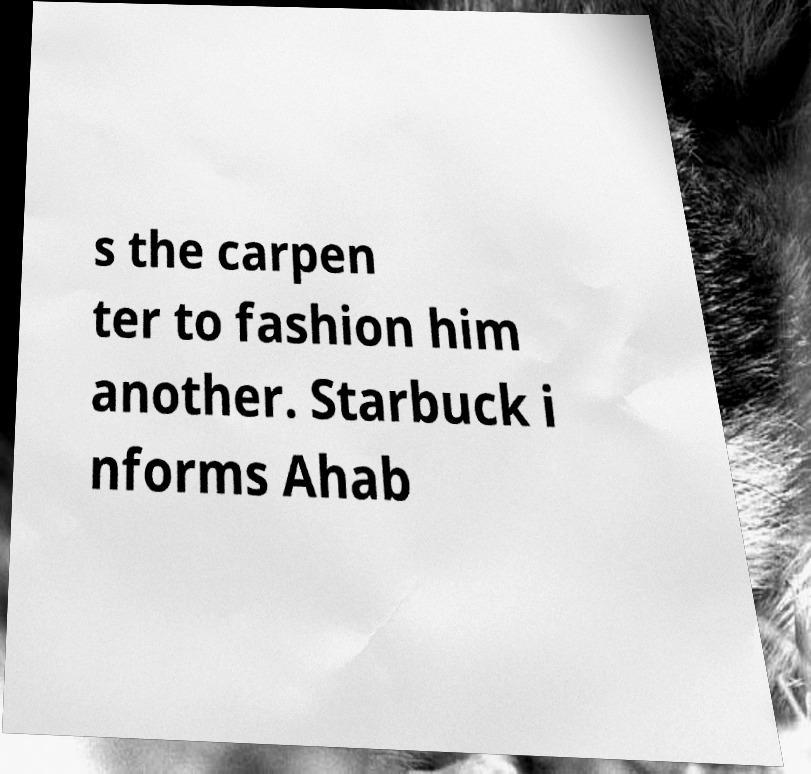Can you read and provide the text displayed in the image?This photo seems to have some interesting text. Can you extract and type it out for me? s the carpen ter to fashion him another. Starbuck i nforms Ahab 